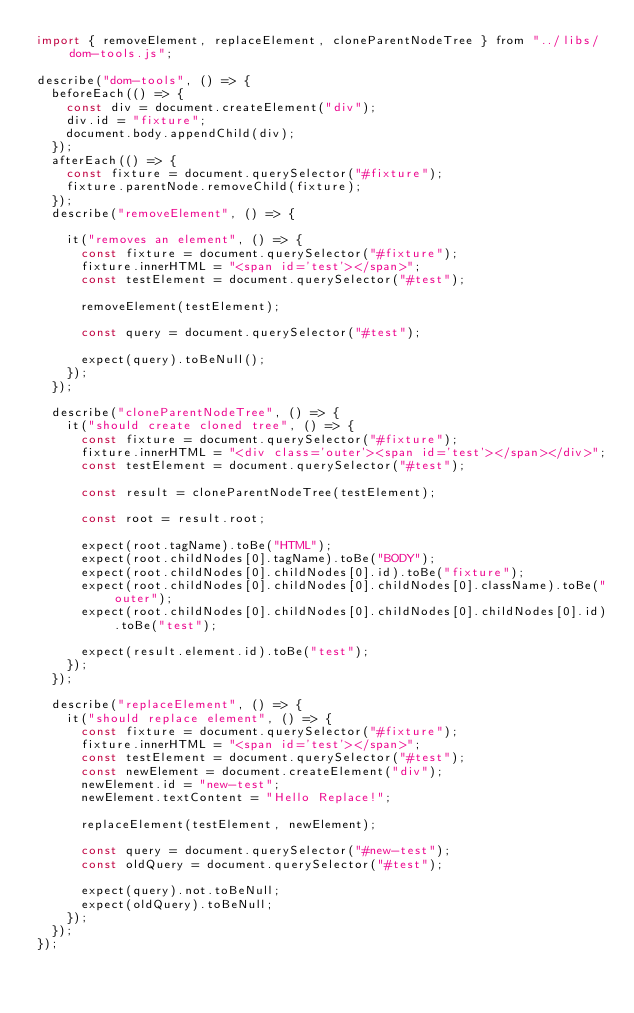<code> <loc_0><loc_0><loc_500><loc_500><_JavaScript_>import { removeElement, replaceElement, cloneParentNodeTree } from "../libs/dom-tools.js";

describe("dom-tools", () => {
  beforeEach(() => {
    const div = document.createElement("div");
    div.id = "fixture";
    document.body.appendChild(div);
  });
  afterEach(() => {
    const fixture = document.querySelector("#fixture");
    fixture.parentNode.removeChild(fixture);
  });
  describe("removeElement", () => {

    it("removes an element", () => {
      const fixture = document.querySelector("#fixture");
      fixture.innerHTML = "<span id='test'></span>";
      const testElement = document.querySelector("#test");

      removeElement(testElement);

      const query = document.querySelector("#test");

      expect(query).toBeNull();
    });
  });

  describe("cloneParentNodeTree", () => {
    it("should create cloned tree", () => {
      const fixture = document.querySelector("#fixture");
      fixture.innerHTML = "<div class='outer'><span id='test'></span></div>";
      const testElement = document.querySelector("#test");

      const result = cloneParentNodeTree(testElement);

      const root = result.root;

      expect(root.tagName).toBe("HTML");
      expect(root.childNodes[0].tagName).toBe("BODY");
      expect(root.childNodes[0].childNodes[0].id).toBe("fixture");
      expect(root.childNodes[0].childNodes[0].childNodes[0].className).toBe("outer");
      expect(root.childNodes[0].childNodes[0].childNodes[0].childNodes[0].id).toBe("test");

      expect(result.element.id).toBe("test");
    });
  });

  describe("replaceElement", () => {
    it("should replace element", () => {
      const fixture = document.querySelector("#fixture");
      fixture.innerHTML = "<span id='test'></span>";
      const testElement = document.querySelector("#test");
      const newElement = document.createElement("div");
      newElement.id = "new-test";
      newElement.textContent = "Hello Replace!";

      replaceElement(testElement, newElement);

      const query = document.querySelector("#new-test");
      const oldQuery = document.querySelector("#test");

      expect(query).not.toBeNull;
      expect(oldQuery).toBeNull;
    });
  });
});</code> 